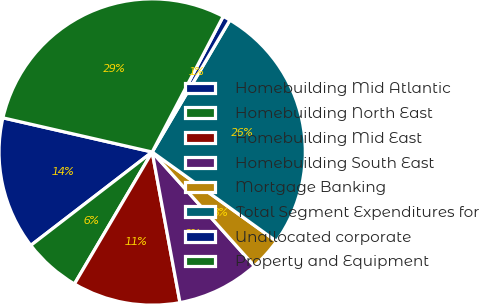Convert chart. <chart><loc_0><loc_0><loc_500><loc_500><pie_chart><fcel>Homebuilding Mid Atlantic<fcel>Homebuilding North East<fcel>Homebuilding Mid East<fcel>Homebuilding South East<fcel>Mortgage Banking<fcel>Total Segment Expenditures for<fcel>Unallocated corporate<fcel>Property and Equipment<nl><fcel>14.02%<fcel>6.09%<fcel>11.38%<fcel>8.73%<fcel>3.45%<fcel>26.44%<fcel>0.8%<fcel>29.09%<nl></chart> 